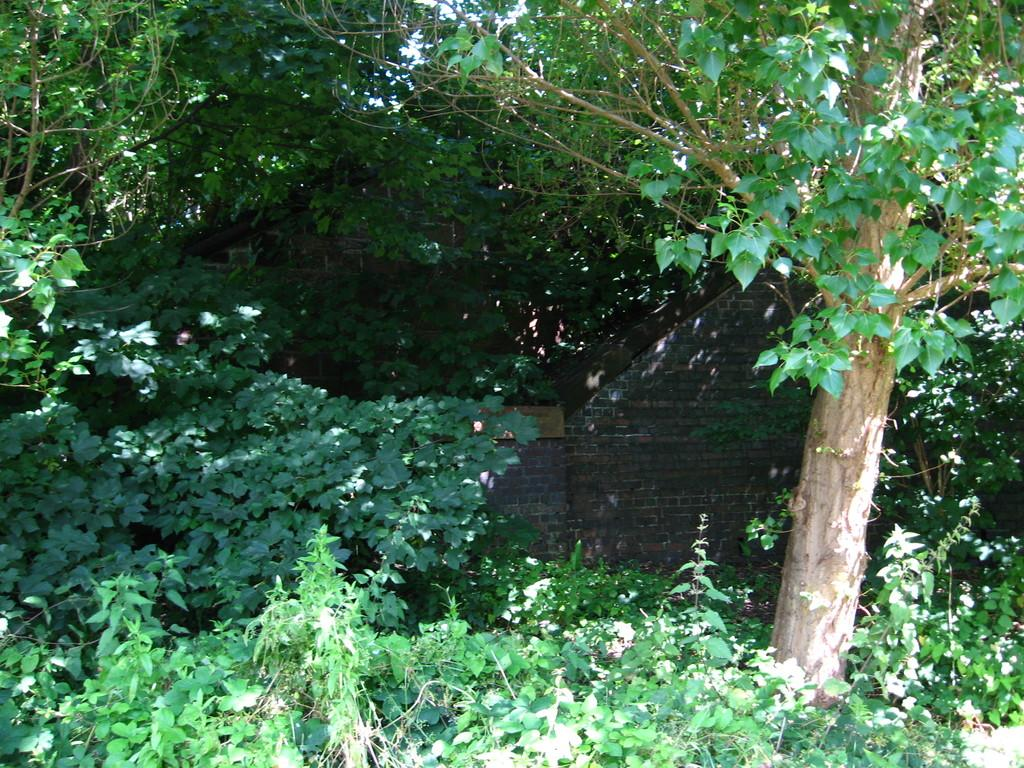What type of natural elements can be seen in the image? There are trees and plants in the image. What type of material is used for construction is visible in the image? There is a wall made of bricks in the image. What type of yarn is being used to decorate the trees in the image? There is no yarn present in the image; the trees and plants are not decorated with any yarn. 